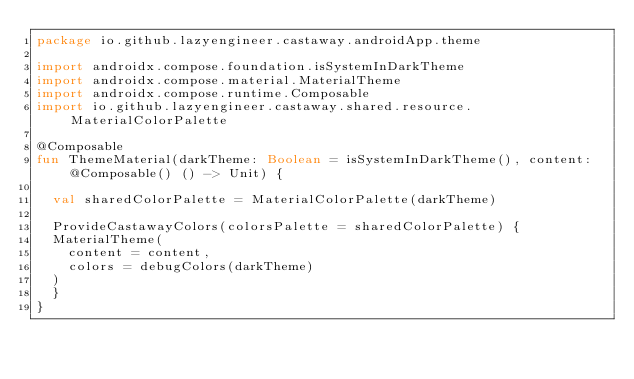Convert code to text. <code><loc_0><loc_0><loc_500><loc_500><_Kotlin_>package io.github.lazyengineer.castaway.androidApp.theme

import androidx.compose.foundation.isSystemInDarkTheme
import androidx.compose.material.MaterialTheme
import androidx.compose.runtime.Composable
import io.github.lazyengineer.castaway.shared.resource.MaterialColorPalette

@Composable
fun ThemeMaterial(darkTheme: Boolean = isSystemInDarkTheme(), content: @Composable() () -> Unit) {

  val sharedColorPalette = MaterialColorPalette(darkTheme)

  ProvideCastawayColors(colorsPalette = sharedColorPalette) {
	MaterialTheme(
	  content = content,
	  colors = debugColors(darkTheme)
	)
  }
}
</code> 